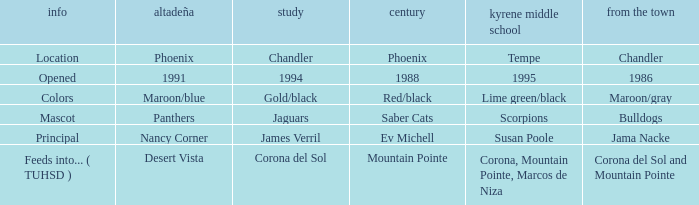WHich kind of Aprende has a Centennial of 1988? 1994.0. 